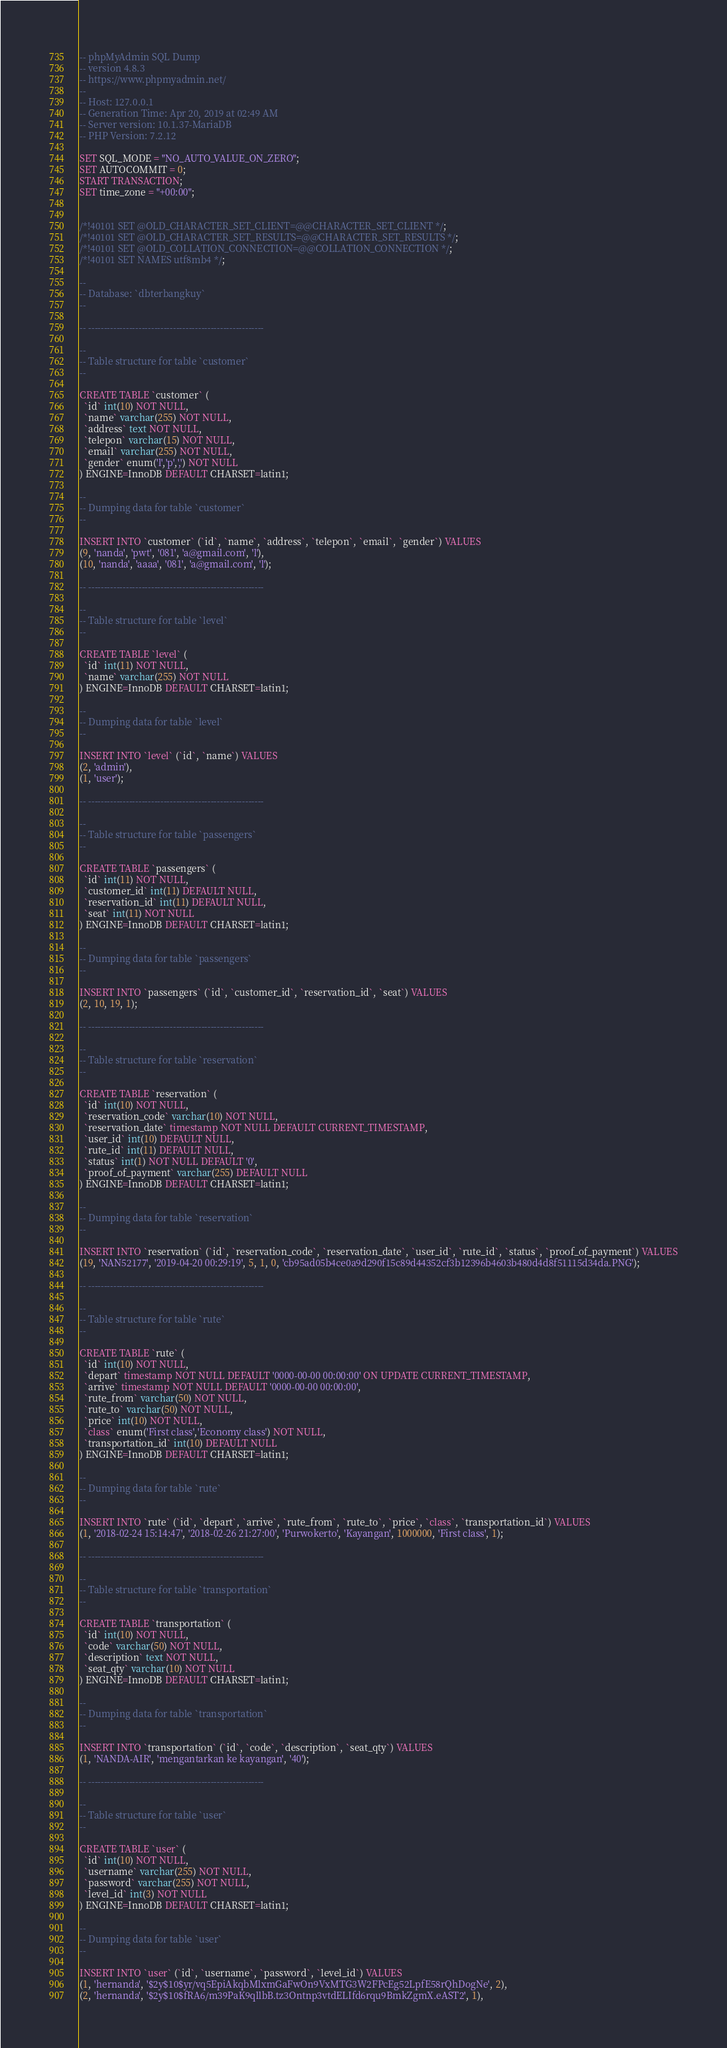Convert code to text. <code><loc_0><loc_0><loc_500><loc_500><_SQL_>-- phpMyAdmin SQL Dump
-- version 4.8.3
-- https://www.phpmyadmin.net/
--
-- Host: 127.0.0.1
-- Generation Time: Apr 20, 2019 at 02:49 AM
-- Server version: 10.1.37-MariaDB
-- PHP Version: 7.2.12

SET SQL_MODE = "NO_AUTO_VALUE_ON_ZERO";
SET AUTOCOMMIT = 0;
START TRANSACTION;
SET time_zone = "+00:00";


/*!40101 SET @OLD_CHARACTER_SET_CLIENT=@@CHARACTER_SET_CLIENT */;
/*!40101 SET @OLD_CHARACTER_SET_RESULTS=@@CHARACTER_SET_RESULTS */;
/*!40101 SET @OLD_COLLATION_CONNECTION=@@COLLATION_CONNECTION */;
/*!40101 SET NAMES utf8mb4 */;

--
-- Database: `dbterbangkuy`
--

-- --------------------------------------------------------

--
-- Table structure for table `customer`
--

CREATE TABLE `customer` (
  `id` int(10) NOT NULL,
  `name` varchar(255) NOT NULL,
  `address` text NOT NULL,
  `telepon` varchar(15) NOT NULL,
  `email` varchar(255) NOT NULL,
  `gender` enum('l','p',',') NOT NULL
) ENGINE=InnoDB DEFAULT CHARSET=latin1;

--
-- Dumping data for table `customer`
--

INSERT INTO `customer` (`id`, `name`, `address`, `telepon`, `email`, `gender`) VALUES
(9, 'nanda', 'pwt', '081', 'a@gmail.com', 'l'),
(10, 'nanda', 'aaaa', '081', 'a@gmail.com', 'l');

-- --------------------------------------------------------

--
-- Table structure for table `level`
--

CREATE TABLE `level` (
  `id` int(11) NOT NULL,
  `name` varchar(255) NOT NULL
) ENGINE=InnoDB DEFAULT CHARSET=latin1;

--
-- Dumping data for table `level`
--

INSERT INTO `level` (`id`, `name`) VALUES
(2, 'admin'),
(1, 'user');

-- --------------------------------------------------------

--
-- Table structure for table `passengers`
--

CREATE TABLE `passengers` (
  `id` int(11) NOT NULL,
  `customer_id` int(11) DEFAULT NULL,
  `reservation_id` int(11) DEFAULT NULL,
  `seat` int(11) NOT NULL
) ENGINE=InnoDB DEFAULT CHARSET=latin1;

--
-- Dumping data for table `passengers`
--

INSERT INTO `passengers` (`id`, `customer_id`, `reservation_id`, `seat`) VALUES
(2, 10, 19, 1);

-- --------------------------------------------------------

--
-- Table structure for table `reservation`
--

CREATE TABLE `reservation` (
  `id` int(10) NOT NULL,
  `reservation_code` varchar(10) NOT NULL,
  `reservation_date` timestamp NOT NULL DEFAULT CURRENT_TIMESTAMP,
  `user_id` int(10) DEFAULT NULL,
  `rute_id` int(11) DEFAULT NULL,
  `status` int(1) NOT NULL DEFAULT '0',
  `proof_of_payment` varchar(255) DEFAULT NULL
) ENGINE=InnoDB DEFAULT CHARSET=latin1;

--
-- Dumping data for table `reservation`
--

INSERT INTO `reservation` (`id`, `reservation_code`, `reservation_date`, `user_id`, `rute_id`, `status`, `proof_of_payment`) VALUES
(19, 'NAN52177', '2019-04-20 00:29:19', 5, 1, 0, 'cb95ad05b4ce0a9d290f15c89d44352cf3b12396b4603b480d4d8f51115d34da.PNG');

-- --------------------------------------------------------

--
-- Table structure for table `rute`
--

CREATE TABLE `rute` (
  `id` int(10) NOT NULL,
  `depart` timestamp NOT NULL DEFAULT '0000-00-00 00:00:00' ON UPDATE CURRENT_TIMESTAMP,
  `arrive` timestamp NOT NULL DEFAULT '0000-00-00 00:00:00',
  `rute_from` varchar(50) NOT NULL,
  `rute_to` varchar(50) NOT NULL,
  `price` int(10) NOT NULL,
  `class` enum('First class','Economy class') NOT NULL,
  `transportation_id` int(10) DEFAULT NULL
) ENGINE=InnoDB DEFAULT CHARSET=latin1;

--
-- Dumping data for table `rute`
--

INSERT INTO `rute` (`id`, `depart`, `arrive`, `rute_from`, `rute_to`, `price`, `class`, `transportation_id`) VALUES
(1, '2018-02-24 15:14:47', '2018-02-26 21:27:00', 'Purwokerto', 'Kayangan', 1000000, 'First class', 1);

-- --------------------------------------------------------

--
-- Table structure for table `transportation`
--

CREATE TABLE `transportation` (
  `id` int(10) NOT NULL,
  `code` varchar(50) NOT NULL,
  `description` text NOT NULL,
  `seat_qty` varchar(10) NOT NULL
) ENGINE=InnoDB DEFAULT CHARSET=latin1;

--
-- Dumping data for table `transportation`
--

INSERT INTO `transportation` (`id`, `code`, `description`, `seat_qty`) VALUES
(1, 'NANDA-AIR', 'mengantarkan ke kayangan', '40');

-- --------------------------------------------------------

--
-- Table structure for table `user`
--

CREATE TABLE `user` (
  `id` int(10) NOT NULL,
  `username` varchar(255) NOT NULL,
  `password` varchar(255) NOT NULL,
  `level_id` int(3) NOT NULL
) ENGINE=InnoDB DEFAULT CHARSET=latin1;

--
-- Dumping data for table `user`
--

INSERT INTO `user` (`id`, `username`, `password`, `level_id`) VALUES
(1, 'hernanda', '$2y$10$yr/vq5EpiAkqbMlxmGaFwOn9VxMTG3W2FPcEg52LpfE58rQhDogNe', 2),
(2, 'hernanda', '$2y$10$fRA6/m39PaK9qllbB.tz3Ontnp3vtdELIfd6rqu9BmkZgmX.eAST2', 1),</code> 